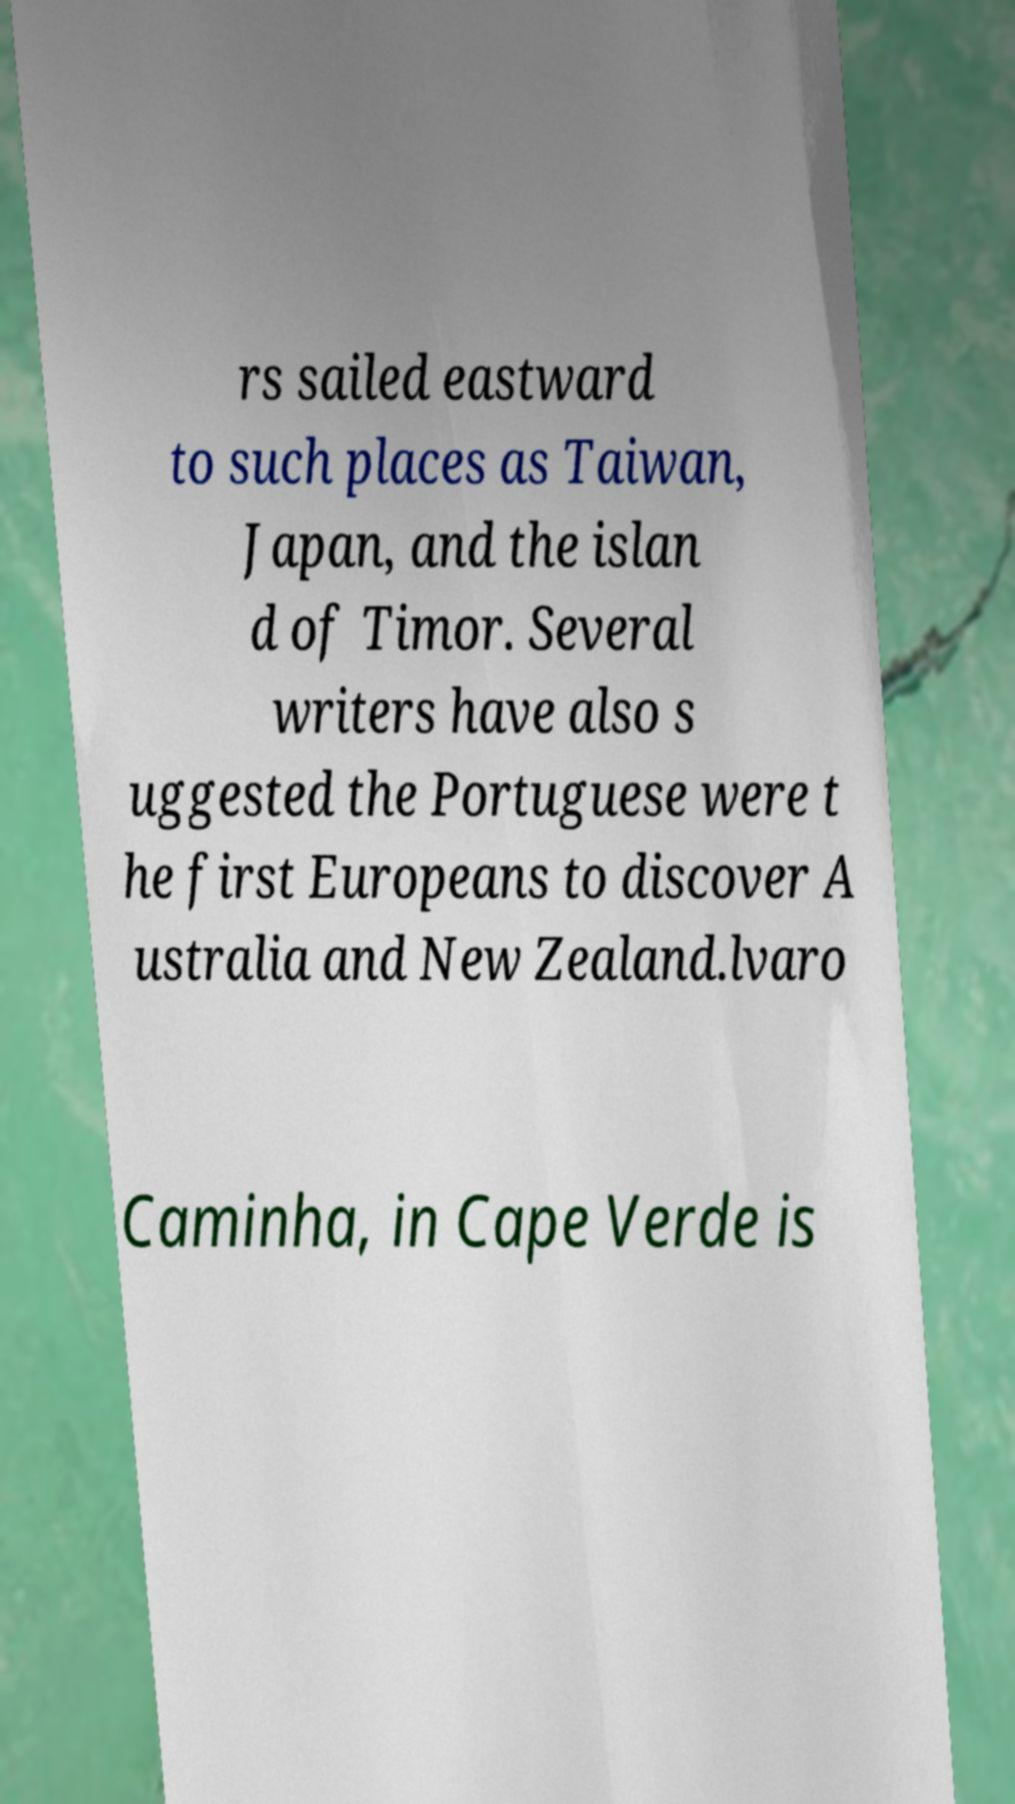Can you read and provide the text displayed in the image?This photo seems to have some interesting text. Can you extract and type it out for me? rs sailed eastward to such places as Taiwan, Japan, and the islan d of Timor. Several writers have also s uggested the Portuguese were t he first Europeans to discover A ustralia and New Zealand.lvaro Caminha, in Cape Verde is 